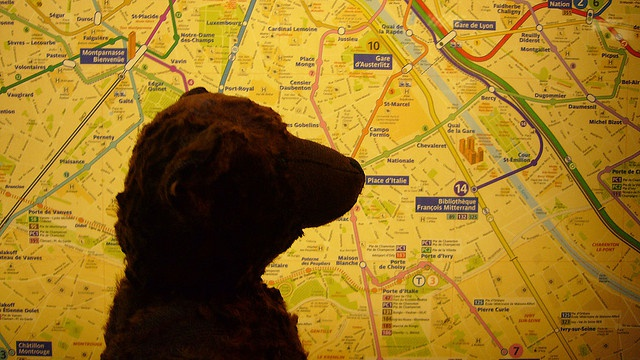Describe the objects in this image and their specific colors. I can see bear in orange, black, maroon, and olive tones and teddy bear in orange, black, maroon, and olive tones in this image. 